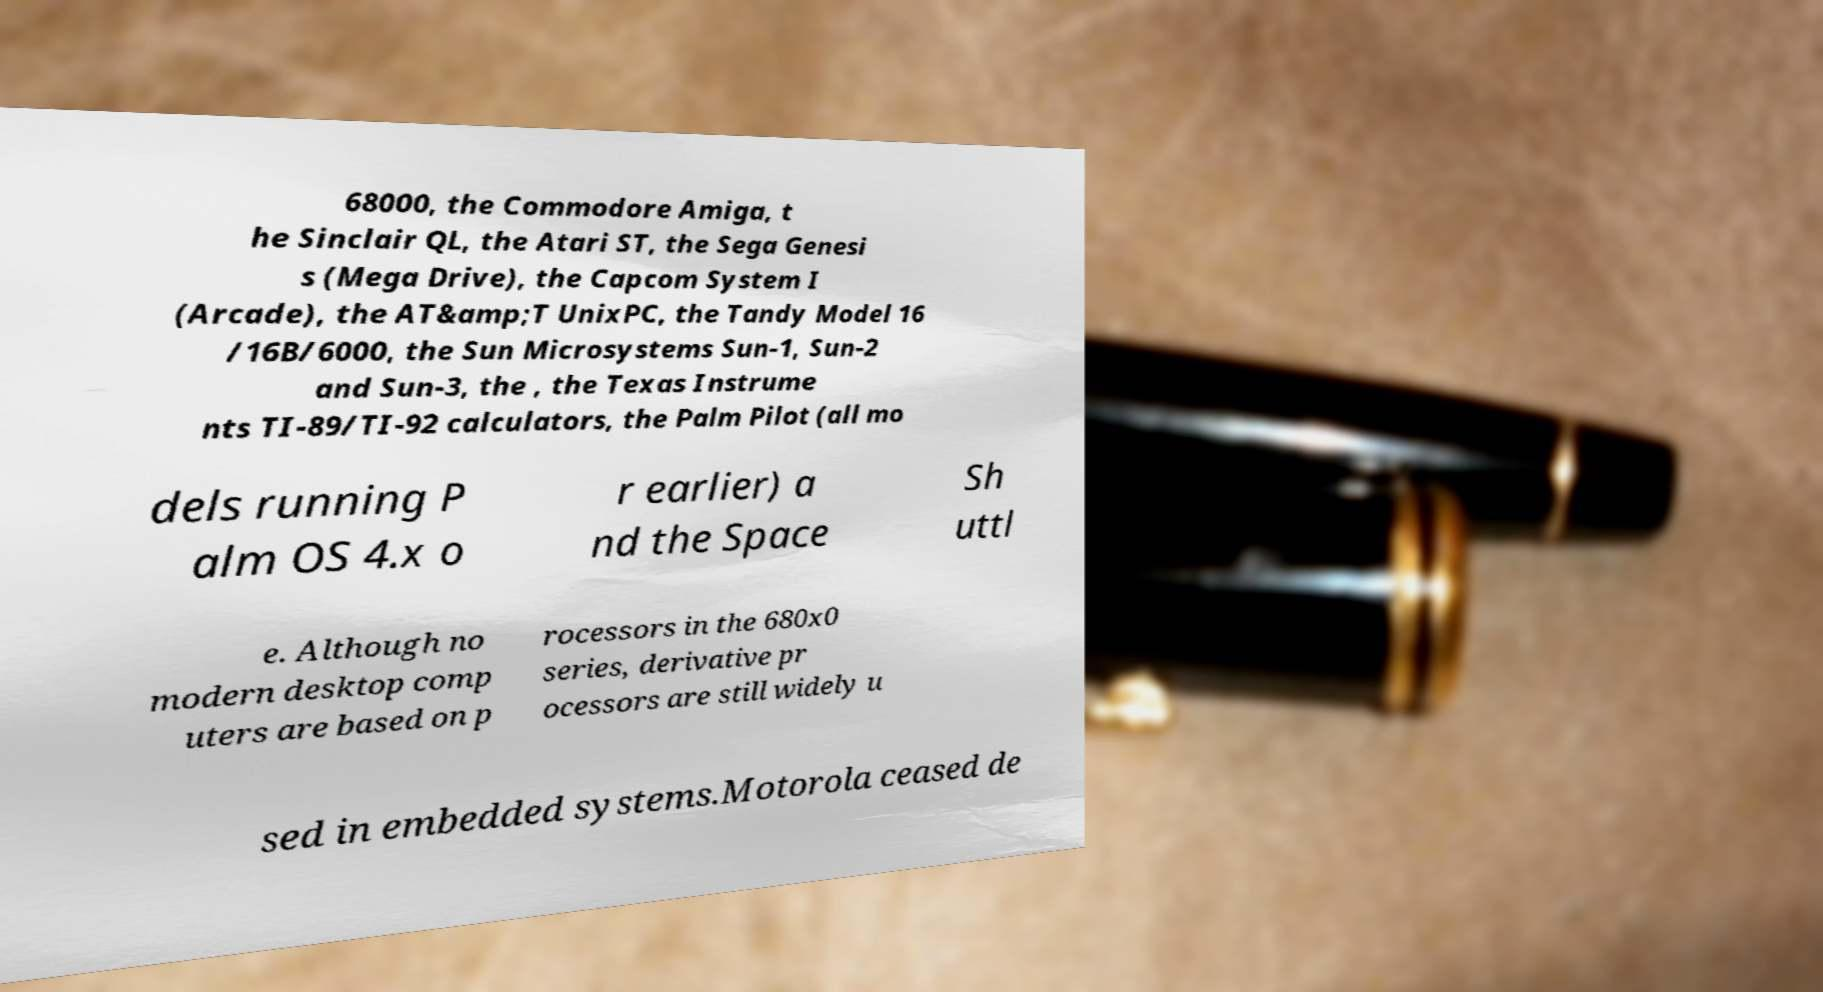Please read and relay the text visible in this image. What does it say? 68000, the Commodore Amiga, t he Sinclair QL, the Atari ST, the Sega Genesi s (Mega Drive), the Capcom System I (Arcade), the AT&amp;T UnixPC, the Tandy Model 16 /16B/6000, the Sun Microsystems Sun-1, Sun-2 and Sun-3, the , the Texas Instrume nts TI-89/TI-92 calculators, the Palm Pilot (all mo dels running P alm OS 4.x o r earlier) a nd the Space Sh uttl e. Although no modern desktop comp uters are based on p rocessors in the 680x0 series, derivative pr ocessors are still widely u sed in embedded systems.Motorola ceased de 